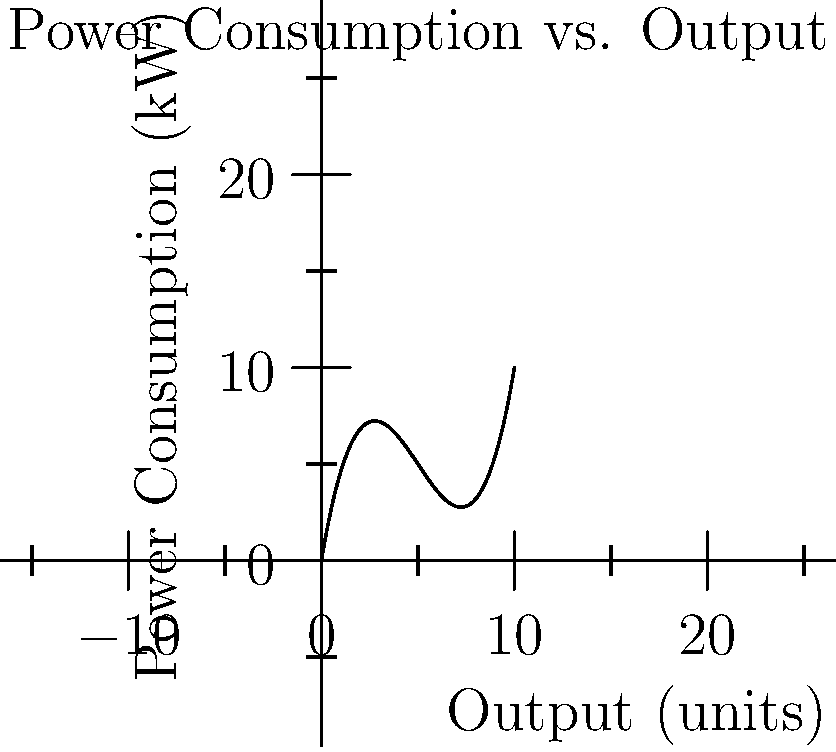The graph shows the power consumption of a machine versus its output. Find the output level that minimizes power consumption per unit of output. Round your answer to the nearest whole number. To find the optimal operating point, we need to minimize the power consumption per unit of output. This is equivalent to finding the minimum of the function $f(x)/x$, where $f(x)$ is the power consumption and $x$ is the output.

Steps:
1) Let $g(x) = f(x)/x$ be the function we want to minimize.
2) To find the minimum, we need to find where $g'(x) = 0$.
3) Using the quotient rule, we get:
   $$g'(x) = \frac{xf'(x) - f(x)}{x^2} = 0$$
4) This is equivalent to solving:
   $$xf'(x) - f(x) = 0$$
5) From the graph, we can estimate that $f(x) = 0.1x^3 - 1.5x^2 + 6x$
6) Therefore, $f'(x) = 0.3x^2 - 3x + 6$
7) Substituting into the equation from step 4:
   $$x(0.3x^2 - 3x + 6) - (0.1x^3 - 1.5x^2 + 6x) = 0$$
8) Simplifying:
   $$0.3x^3 - 3x^2 + 6x - 0.1x^3 + 1.5x^2 - 6x = 0$$
   $$0.2x^3 - 1.5x^2 = 0$$
   $$x^2(0.2x - 1.5) = 0$$
9) Solving this equation:
   $x = 0$ (which we can discard as it's not a valid operating point)
   $0.2x - 1.5 = 0$
   $x = 7.5$
10) Rounding to the nearest whole number, we get 8.
Answer: 8 units 